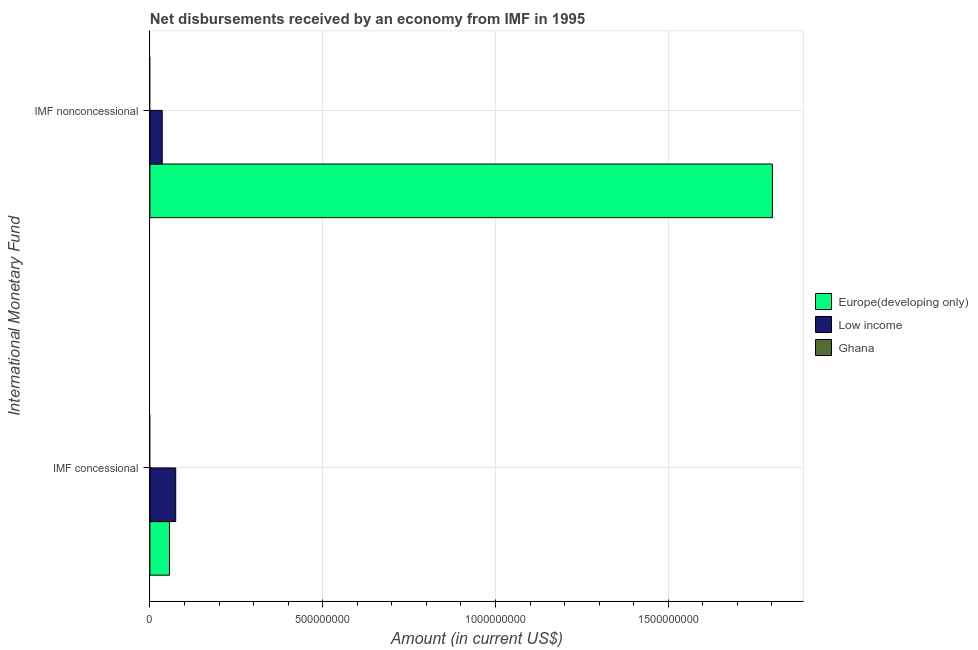How many different coloured bars are there?
Make the answer very short. 2. How many groups of bars are there?
Your response must be concise. 2. Are the number of bars per tick equal to the number of legend labels?
Your answer should be compact. No. How many bars are there on the 1st tick from the top?
Your answer should be compact. 2. How many bars are there on the 1st tick from the bottom?
Provide a succinct answer. 2. What is the label of the 1st group of bars from the top?
Your answer should be very brief. IMF nonconcessional. What is the net concessional disbursements from imf in Low income?
Provide a succinct answer. 7.47e+07. Across all countries, what is the maximum net non concessional disbursements from imf?
Make the answer very short. 1.80e+09. Across all countries, what is the minimum net concessional disbursements from imf?
Your answer should be compact. 0. In which country was the net concessional disbursements from imf maximum?
Offer a very short reply. Low income. What is the total net concessional disbursements from imf in the graph?
Ensure brevity in your answer.  1.31e+08. What is the difference between the net non concessional disbursements from imf in Europe(developing only) and that in Low income?
Keep it short and to the point. 1.77e+09. What is the difference between the net non concessional disbursements from imf in Europe(developing only) and the net concessional disbursements from imf in Low income?
Make the answer very short. 1.73e+09. What is the average net non concessional disbursements from imf per country?
Your answer should be compact. 6.12e+08. What is the difference between the net concessional disbursements from imf and net non concessional disbursements from imf in Europe(developing only)?
Keep it short and to the point. -1.74e+09. In how many countries, is the net concessional disbursements from imf greater than 700000000 US$?
Keep it short and to the point. 0. What is the ratio of the net concessional disbursements from imf in Low income to that in Europe(developing only)?
Provide a short and direct response. 1.32. Are all the bars in the graph horizontal?
Provide a succinct answer. Yes. How many countries are there in the graph?
Your answer should be compact. 3. What is the difference between two consecutive major ticks on the X-axis?
Your answer should be very brief. 5.00e+08. Are the values on the major ticks of X-axis written in scientific E-notation?
Offer a terse response. No. Does the graph contain any zero values?
Offer a terse response. Yes. Does the graph contain grids?
Provide a short and direct response. Yes. How are the legend labels stacked?
Offer a very short reply. Vertical. What is the title of the graph?
Offer a very short reply. Net disbursements received by an economy from IMF in 1995. What is the label or title of the Y-axis?
Provide a short and direct response. International Monetary Fund. What is the Amount (in current US$) in Europe(developing only) in IMF concessional?
Give a very brief answer. 5.67e+07. What is the Amount (in current US$) of Low income in IMF concessional?
Provide a short and direct response. 7.47e+07. What is the Amount (in current US$) of Europe(developing only) in IMF nonconcessional?
Offer a very short reply. 1.80e+09. What is the Amount (in current US$) of Low income in IMF nonconcessional?
Your answer should be very brief. 3.56e+07. What is the Amount (in current US$) in Ghana in IMF nonconcessional?
Offer a terse response. 0. Across all International Monetary Fund, what is the maximum Amount (in current US$) of Europe(developing only)?
Provide a succinct answer. 1.80e+09. Across all International Monetary Fund, what is the maximum Amount (in current US$) of Low income?
Offer a terse response. 7.47e+07. Across all International Monetary Fund, what is the minimum Amount (in current US$) in Europe(developing only)?
Your answer should be very brief. 5.67e+07. Across all International Monetary Fund, what is the minimum Amount (in current US$) of Low income?
Provide a succinct answer. 3.56e+07. What is the total Amount (in current US$) in Europe(developing only) in the graph?
Provide a short and direct response. 1.86e+09. What is the total Amount (in current US$) in Low income in the graph?
Give a very brief answer. 1.10e+08. What is the difference between the Amount (in current US$) of Europe(developing only) in IMF concessional and that in IMF nonconcessional?
Your answer should be compact. -1.74e+09. What is the difference between the Amount (in current US$) of Low income in IMF concessional and that in IMF nonconcessional?
Provide a succinct answer. 3.91e+07. What is the difference between the Amount (in current US$) in Europe(developing only) in IMF concessional and the Amount (in current US$) in Low income in IMF nonconcessional?
Provide a short and direct response. 2.11e+07. What is the average Amount (in current US$) of Europe(developing only) per International Monetary Fund?
Make the answer very short. 9.29e+08. What is the average Amount (in current US$) in Low income per International Monetary Fund?
Provide a succinct answer. 5.52e+07. What is the difference between the Amount (in current US$) in Europe(developing only) and Amount (in current US$) in Low income in IMF concessional?
Offer a very short reply. -1.80e+07. What is the difference between the Amount (in current US$) in Europe(developing only) and Amount (in current US$) in Low income in IMF nonconcessional?
Provide a short and direct response. 1.77e+09. What is the ratio of the Amount (in current US$) of Europe(developing only) in IMF concessional to that in IMF nonconcessional?
Your response must be concise. 0.03. What is the ratio of the Amount (in current US$) of Low income in IMF concessional to that in IMF nonconcessional?
Make the answer very short. 2.1. What is the difference between the highest and the second highest Amount (in current US$) in Europe(developing only)?
Your response must be concise. 1.74e+09. What is the difference between the highest and the second highest Amount (in current US$) of Low income?
Make the answer very short. 3.91e+07. What is the difference between the highest and the lowest Amount (in current US$) in Europe(developing only)?
Ensure brevity in your answer.  1.74e+09. What is the difference between the highest and the lowest Amount (in current US$) of Low income?
Make the answer very short. 3.91e+07. 